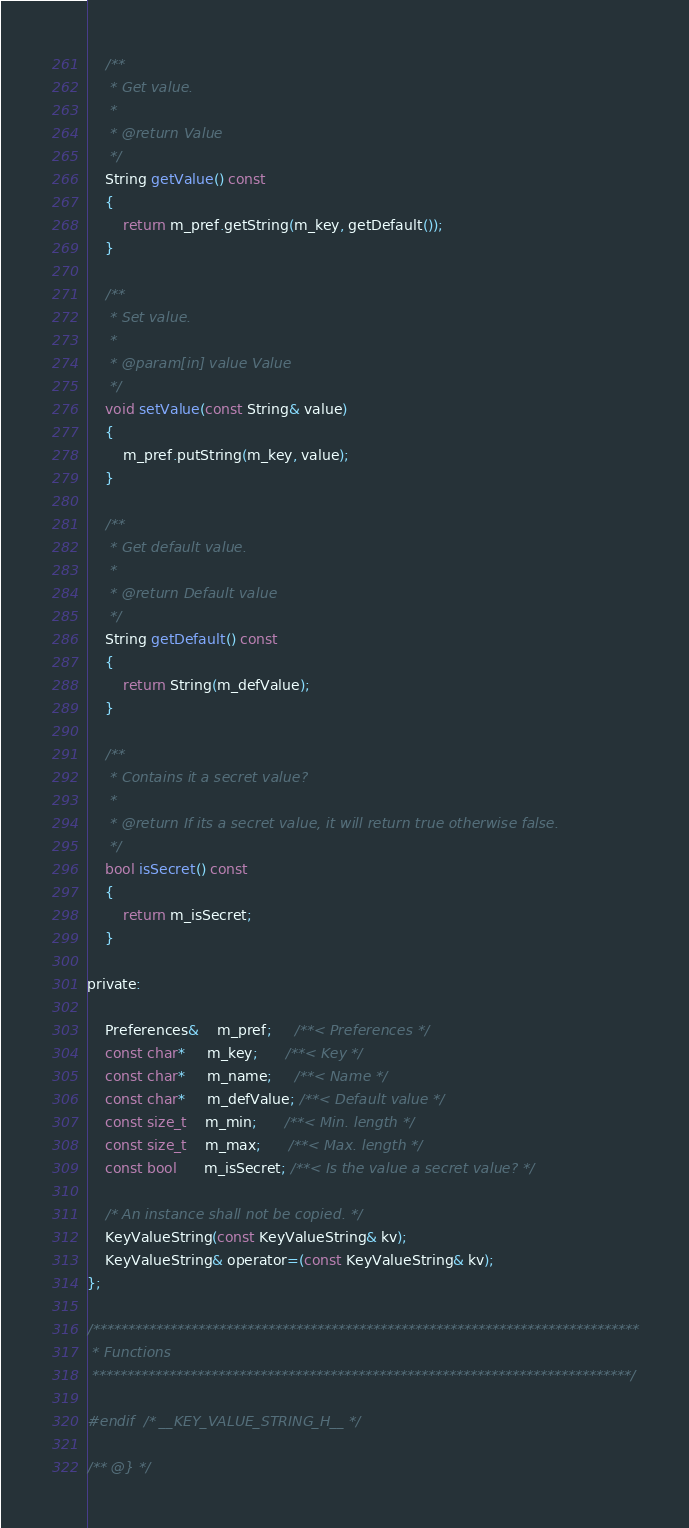Convert code to text. <code><loc_0><loc_0><loc_500><loc_500><_C_>
    /**
     * Get value.
     *
     * @return Value
     */
    String getValue() const
    {
        return m_pref.getString(m_key, getDefault());
    }

    /**
     * Set value.
     *
     * @param[in] value Value
     */
    void setValue(const String& value)
    {
        m_pref.putString(m_key, value);
    }

    /**
     * Get default value.
     *
     * @return Default value
     */
    String getDefault() const
    {
        return String(m_defValue);
    }

    /**
     * Contains it a secret value?
     * 
     * @return If its a secret value, it will return true otherwise false.
     */
    bool isSecret() const
    {
        return m_isSecret;
    }

private:

    Preferences&    m_pref;     /**< Preferences */
    const char*     m_key;      /**< Key */
    const char*     m_name;     /**< Name */
    const char*     m_defValue; /**< Default value */
    const size_t    m_min;      /**< Min. length */
    const size_t    m_max;      /**< Max. length */
    const bool      m_isSecret; /**< Is the value a secret value? */

    /* An instance shall not be copied. */
    KeyValueString(const KeyValueString& kv);
    KeyValueString& operator=(const KeyValueString& kv);
};

/******************************************************************************
 * Functions
 *****************************************************************************/

#endif  /* __KEY_VALUE_STRING_H__ */

/** @} */</code> 